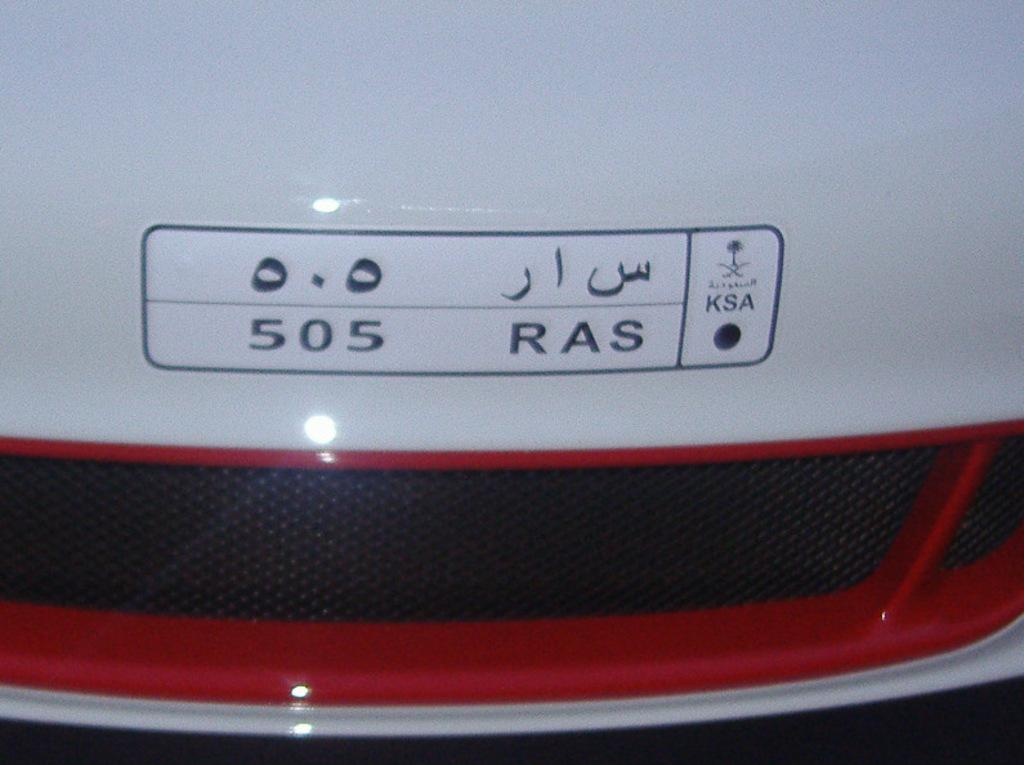What is the main subject of the image? The main subject of the image is a car. Can you describe any specific features of the car? The number plate of the car is visible in the image. What colors are used on the number plate? The number plate is in white and red color. What type of food is being served in the room shown in the image? There is no room or food present in the image; it only features a car with a visible number plate. 